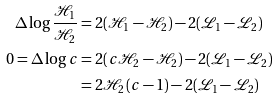<formula> <loc_0><loc_0><loc_500><loc_500>\Delta \log \frac { \mathcal { H } _ { 1 } } { \mathcal { H } _ { 2 } } & = 2 ( \mathcal { H } _ { 1 } - \mathcal { H } _ { 2 } ) - 2 ( \mathcal { L } _ { 1 } - \mathcal { L } _ { 2 } ) \\ 0 = \Delta \log c & = 2 ( c \mathcal { H } _ { 2 } - \mathcal { H } _ { 2 } ) - 2 ( \mathcal { L } _ { 1 } - \mathcal { L } _ { 2 } ) \\ & = 2 \mathcal { H } _ { 2 } ( c - 1 ) - 2 ( \mathcal { L } _ { 1 } - \mathcal { L } _ { 2 } )</formula> 